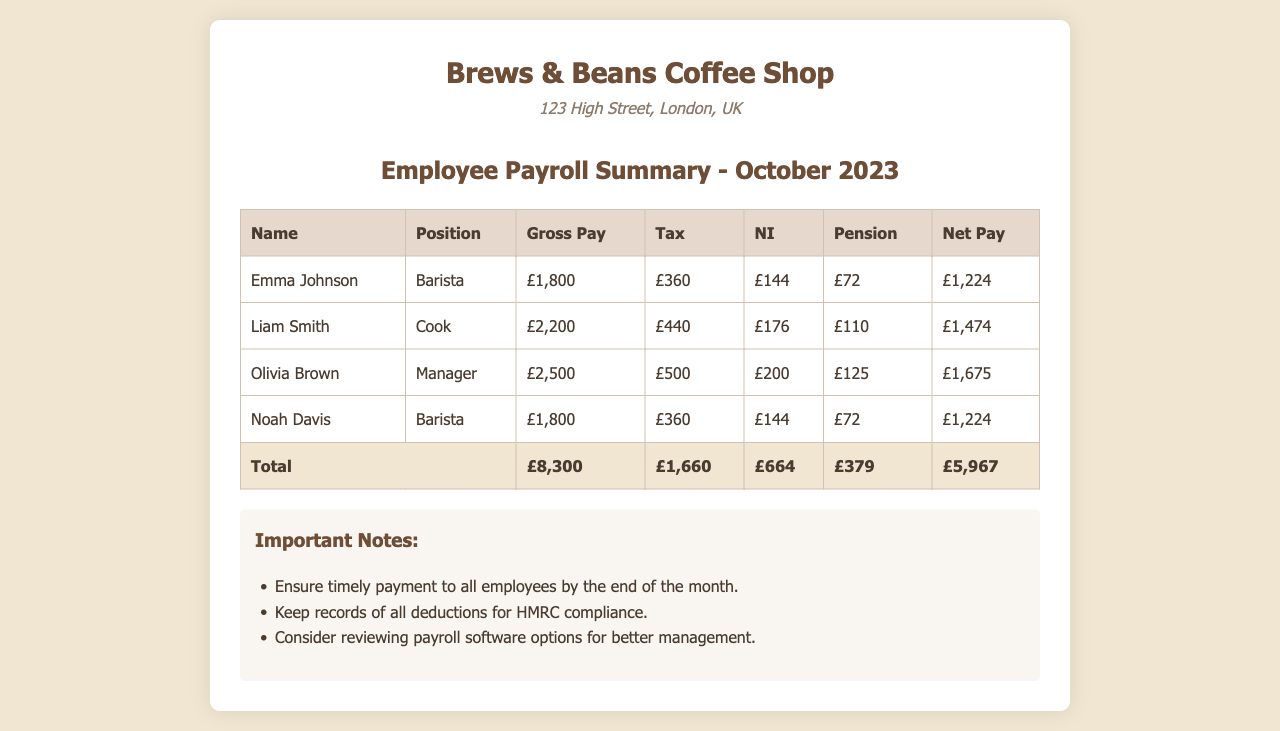What is the total gross pay for the employees? The total gross pay is calculated by summing the gross pay of all employees listed in the document, which is £1,800 + £2,200 + £2,500 + £1,800 = £8,300.
Answer: £8,300 How much is Liam Smith's net pay? Liam Smith's net pay is explicitly stated in the document as £1,474.
Answer: £1,474 Which employee has the highest gross pay? The employee with the highest gross pay is identified in the document as Olivia Brown, who has a gross pay of £2,500.
Answer: Olivia Brown What is the total amount deducted for tax? The total tax deductions are calculated by summing the tax for all employees, which is £360 + £440 + £500 + £360 = £1,660.
Answer: £1,660 How many employees are listed in the payroll summary? The document lists four employees in the payroll summary.
Answer: Four What is the total net pay for all employees? The total net pay is calculated by summing the net pay of all employees, which is £1,224 + £1,474 + £1,675 + £1,224 = £5,697.
Answer: £5,697 What position does Noah Davis hold? Noah Davis's position is mentioned in the document as Barista.
Answer: Barista What are the important notes regarding payroll? The notes highlight the importance of timely payments, record-keeping for deductions, and considering payroll software options.
Answer: Timely payment, record-keeping, payroll software How much was deducted for National Insurance (NI) in total? The total NI deductions for all employees is calculated from the document as £144 + £176 + £200 + £144 = £664.
Answer: £664 